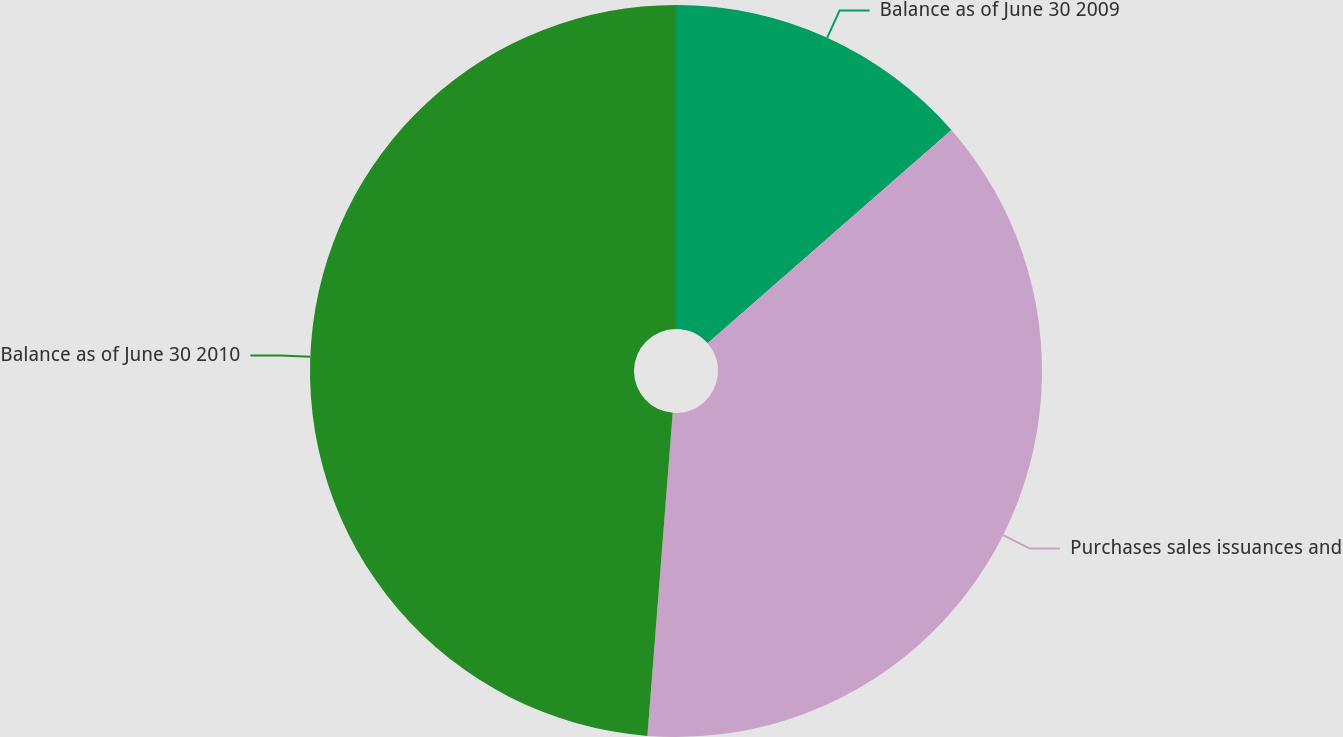Convert chart to OTSL. <chart><loc_0><loc_0><loc_500><loc_500><pie_chart><fcel>Balance as of June 30 2009<fcel>Purchases sales issuances and<fcel>Balance as of June 30 2010<nl><fcel>13.56%<fcel>37.69%<fcel>48.76%<nl></chart> 